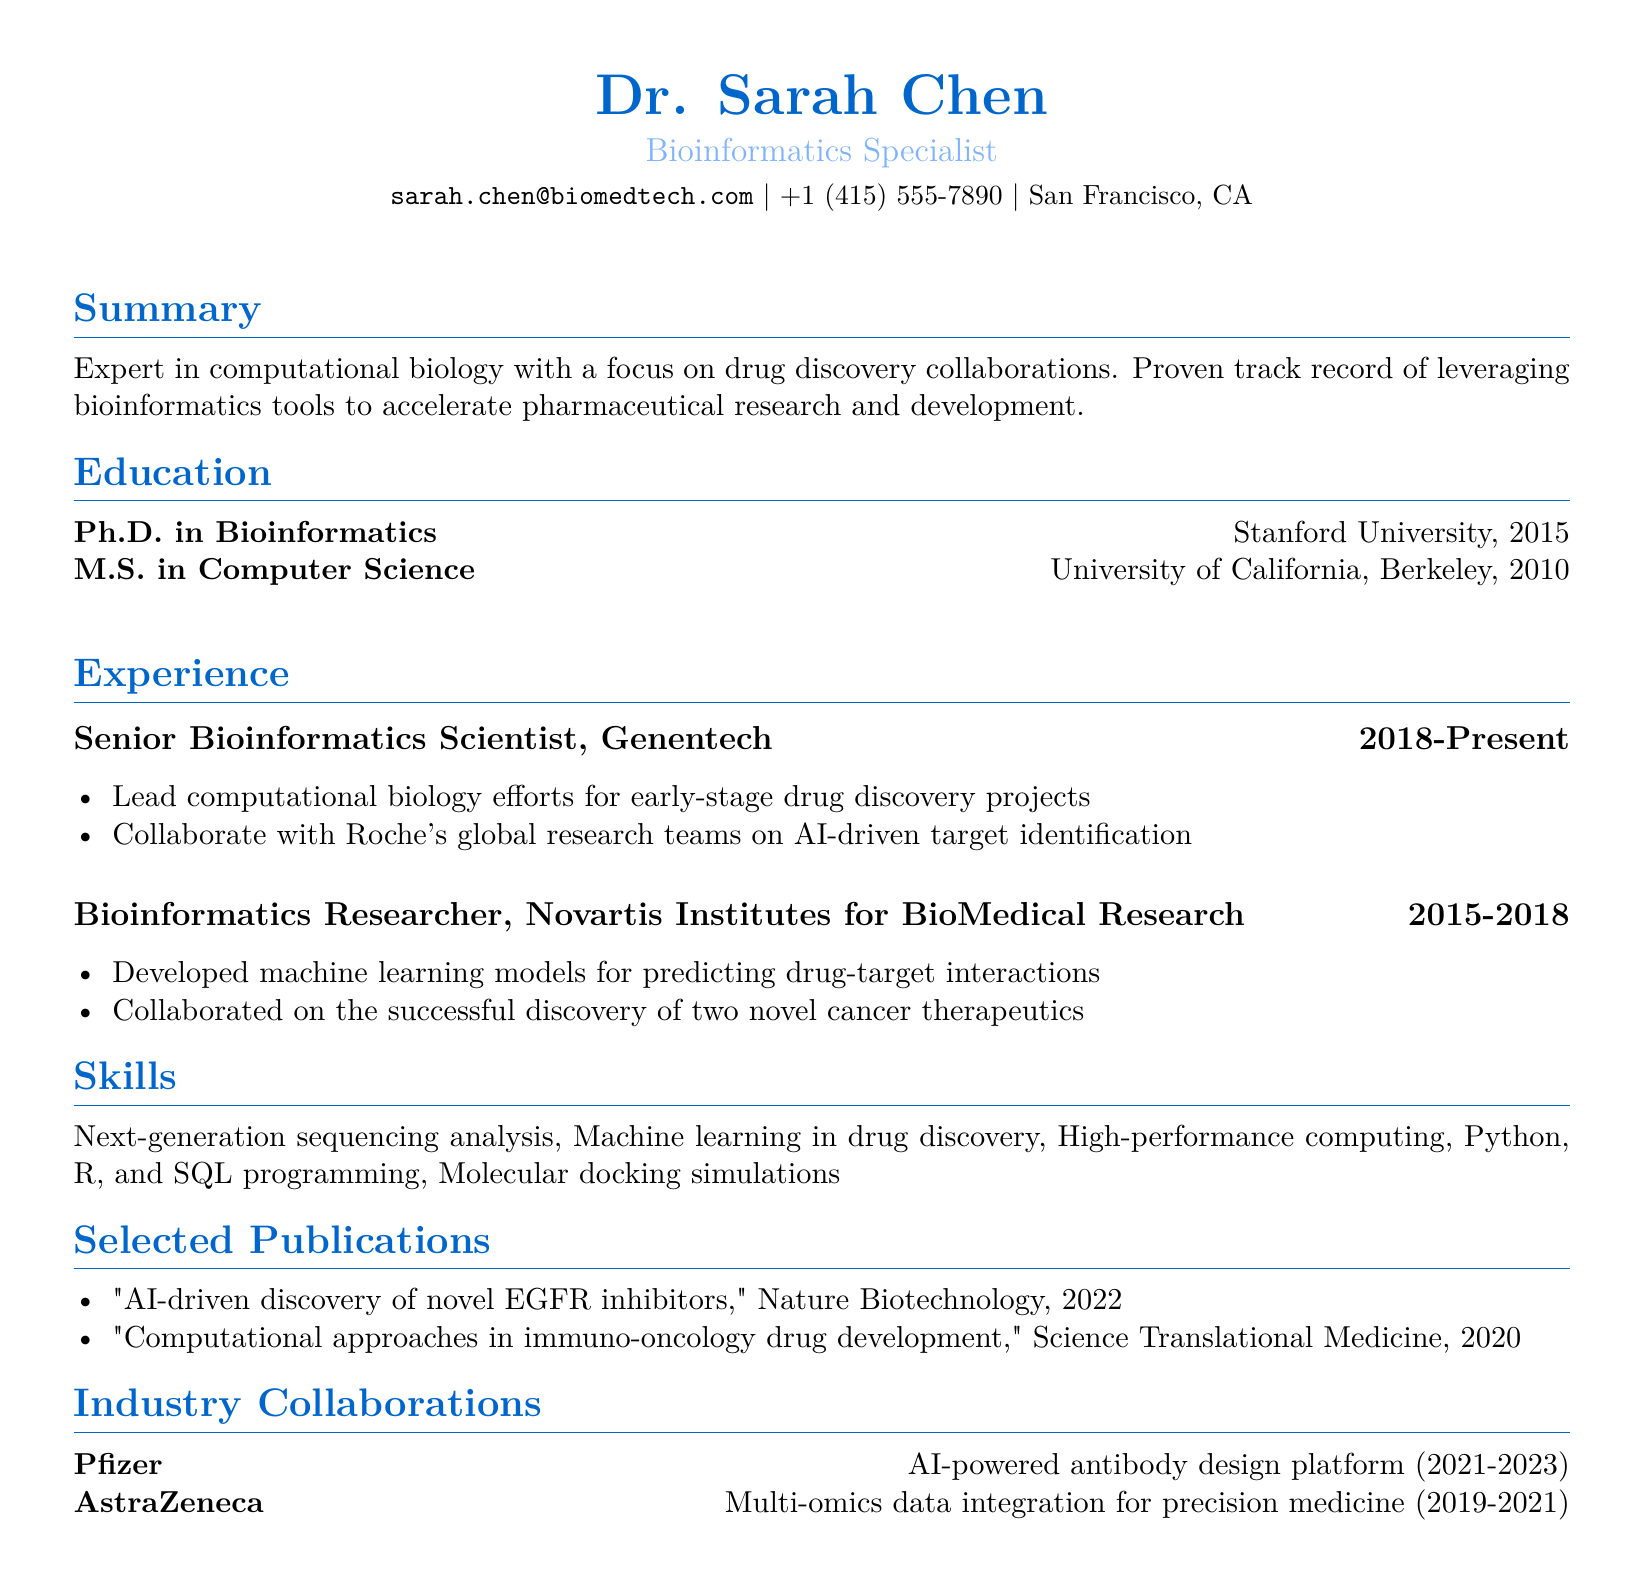What is the name of the individual? The name of the individual is listed at the top of the document.
Answer: Dr. Sarah Chen What is the title of the document? The title indicates the professional role of the individual and can be found prominently below the name.
Answer: Bioinformatics Specialist In which year did Dr. Sarah Chen complete her Ph.D.? The year of the Ph.D. completion is provided in the education section of the document.
Answer: 2015 How long has Dr. Sarah Chen worked at Genentech? The duration of employment at Genentech is specified in the experience section.
Answer: 5 years (2018-Present) What project did Dr. Sarah Chen collaborate on with Pfizer? The specific project details are listed in the collaborations section of the document.
Answer: AI-powered antibody design platform Which programming languages is Dr. Sarah Chen skilled in? The skills section lists the programming languages the individual is proficient in.
Answer: Python, R, and SQL programming What kind of models did Dr. Chen develop while at Novartis? The responsibilities include specifics about the type of models developed during her tenure at Novartis.
Answer: Machine learning models Which journal published Dr. Chen's article on EGFR inhibitors? The document lists specific publications along with the names of the journals.
Answer: Nature Biotechnology What is the location of Dr. Sarah Chen's residence? The location is indicated in the personal information section of the document.
Answer: San Francisco, CA 